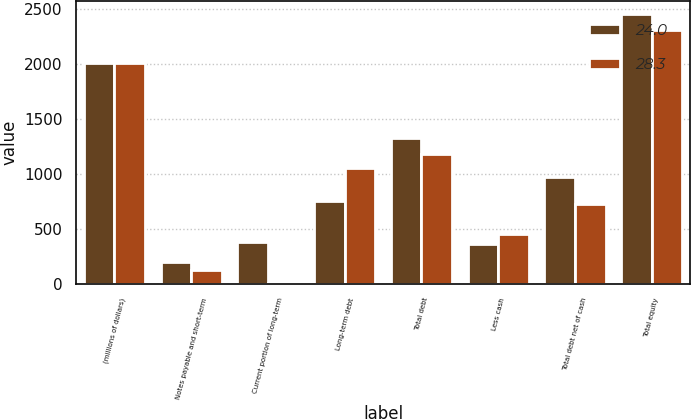<chart> <loc_0><loc_0><loc_500><loc_500><stacked_bar_chart><ecel><fcel>(millions of dollars)<fcel>Notes payable and short-term<fcel>Current portion of long-term<fcel>Long-term debt<fcel>Total debt<fcel>Less cash<fcel>Total debt net of cash<fcel>Total equity<nl><fcel>24<fcel>2011<fcel>196.3<fcel>381.5<fcel>751.3<fcel>1329.1<fcel>359.6<fcel>969.5<fcel>2453<nl><fcel>28.3<fcel>2010<fcel>122.4<fcel>6.1<fcel>1051.9<fcel>1180.4<fcel>449.9<fcel>730.5<fcel>2309.8<nl></chart> 